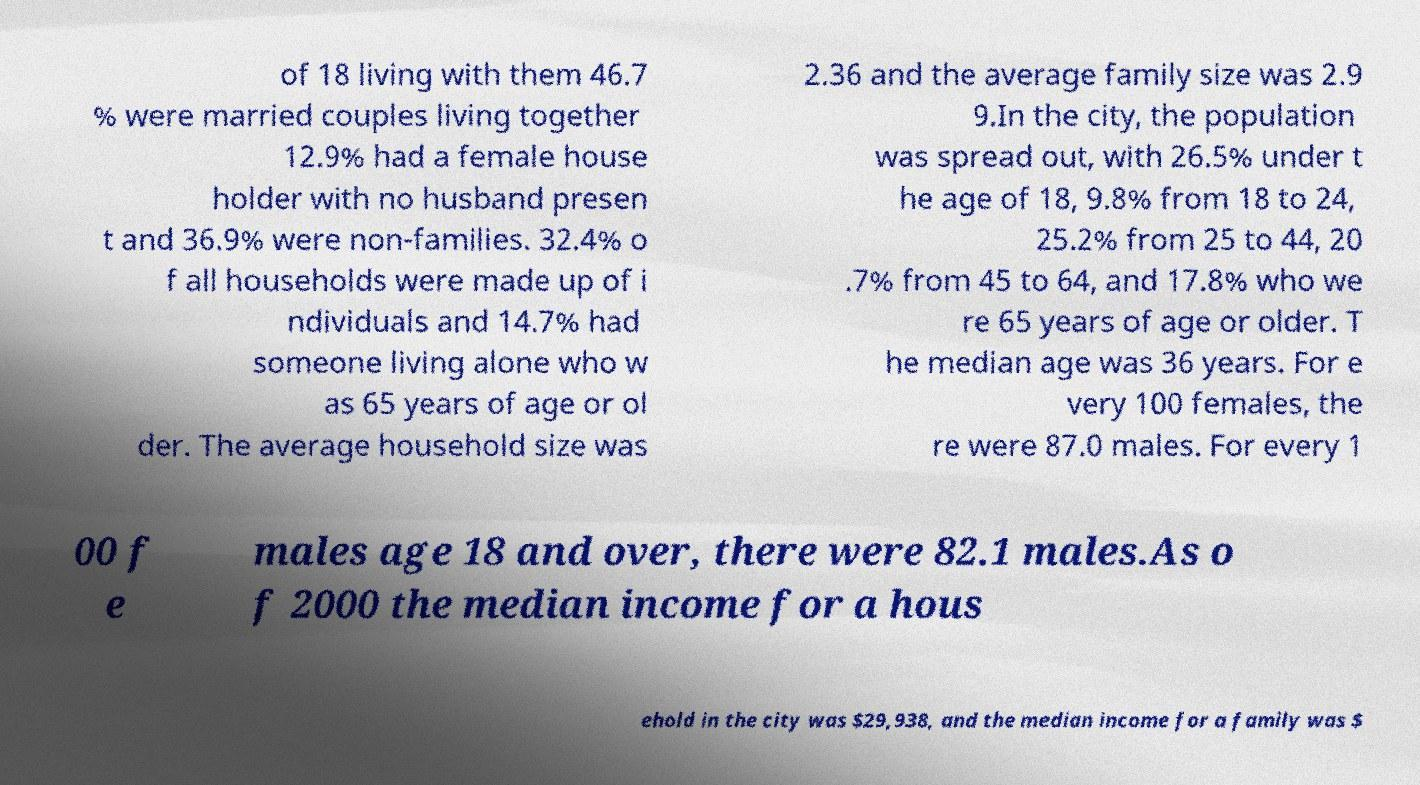What messages or text are displayed in this image? I need them in a readable, typed format. of 18 living with them 46.7 % were married couples living together 12.9% had a female house holder with no husband presen t and 36.9% were non-families. 32.4% o f all households were made up of i ndividuals and 14.7% had someone living alone who w as 65 years of age or ol der. The average household size was 2.36 and the average family size was 2.9 9.In the city, the population was spread out, with 26.5% under t he age of 18, 9.8% from 18 to 24, 25.2% from 25 to 44, 20 .7% from 45 to 64, and 17.8% who we re 65 years of age or older. T he median age was 36 years. For e very 100 females, the re were 87.0 males. For every 1 00 f e males age 18 and over, there were 82.1 males.As o f 2000 the median income for a hous ehold in the city was $29,938, and the median income for a family was $ 